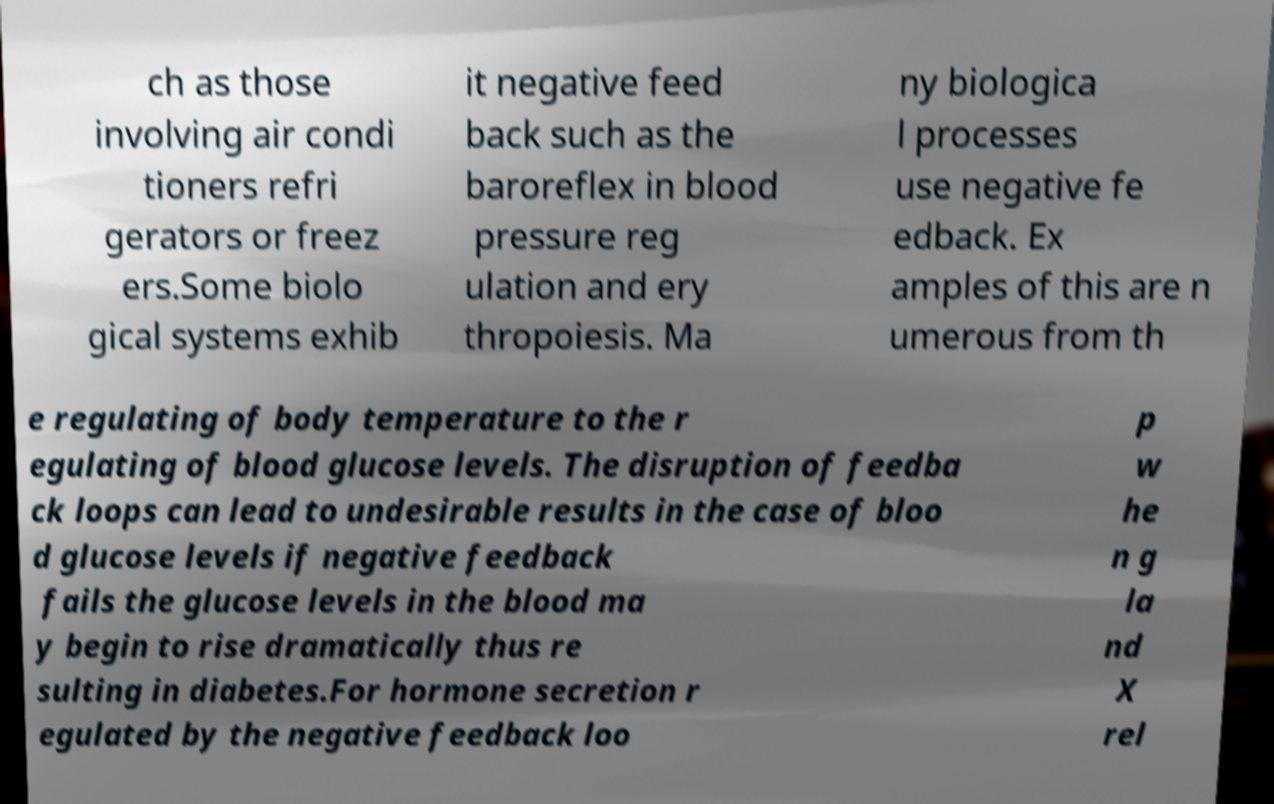Could you extract and type out the text from this image? ch as those involving air condi tioners refri gerators or freez ers.Some biolo gical systems exhib it negative feed back such as the baroreflex in blood pressure reg ulation and ery thropoiesis. Ma ny biologica l processes use negative fe edback. Ex amples of this are n umerous from th e regulating of body temperature to the r egulating of blood glucose levels. The disruption of feedba ck loops can lead to undesirable results in the case of bloo d glucose levels if negative feedback fails the glucose levels in the blood ma y begin to rise dramatically thus re sulting in diabetes.For hormone secretion r egulated by the negative feedback loo p w he n g la nd X rel 